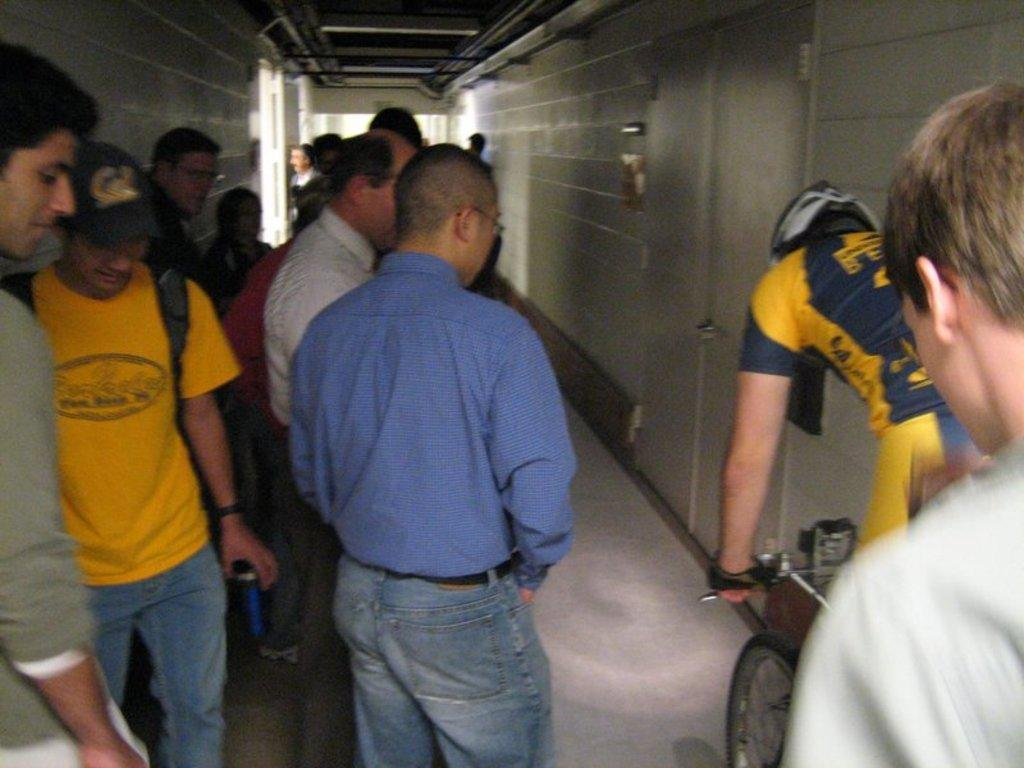How many people are in the image? There is a group of people in the image. What is one person in the group doing? One person is on a bicycle. What type of farm animals can be seen in the image? There are no farm animals present in the image. What year is depicted in the image? The image does not depict a specific year. 